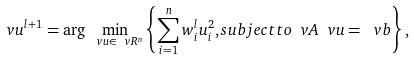<formula> <loc_0><loc_0><loc_500><loc_500>\ v u ^ { l + 1 } = \arg \min _ { \ v u \in \ v R ^ { n } } \left \{ \sum _ { i = 1 } ^ { n } w ^ { l } _ { i } u ^ { 2 } _ { i } , s u b j e c t t o \ v A \ v u = \ v b \right \} ,</formula> 